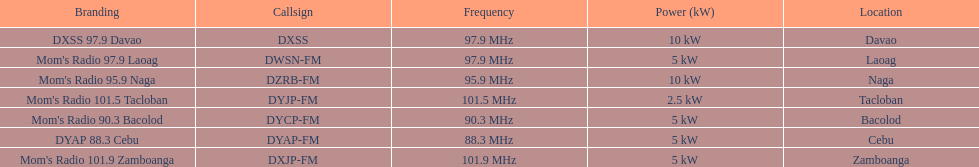How many times is the frequency greater than 95? 5. 